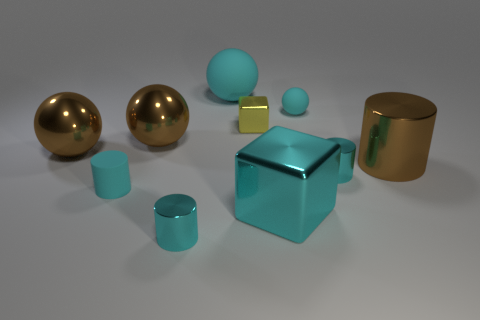Subtract all cyan cylinders. How many were subtracted if there are1cyan cylinders left? 2 Subtract all small matte spheres. How many spheres are left? 3 Add 4 big cyan matte balls. How many big cyan matte balls exist? 5 Subtract all brown spheres. How many spheres are left? 2 Subtract 0 yellow cylinders. How many objects are left? 10 Subtract all cylinders. How many objects are left? 6 Subtract 1 blocks. How many blocks are left? 1 Subtract all green spheres. Subtract all gray cubes. How many spheres are left? 4 Subtract all yellow cubes. How many cyan cylinders are left? 3 Subtract all large metal things. Subtract all large rubber objects. How many objects are left? 5 